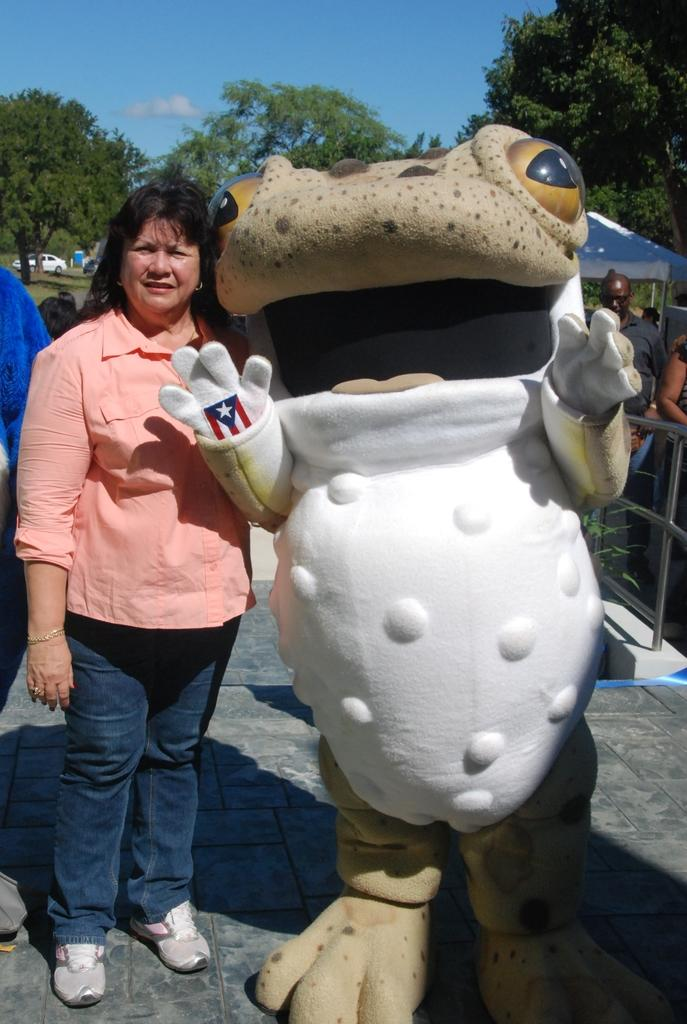Who is present in the image? There is a woman and a mascot in the image. What are the woman and the mascot doing in the image? Both the woman and the mascot are standing on the floor. What can be seen in the background of the image? There are people, a fence, a tent, a car, trees, and some objects in the background of the image. The sky is also visible. How much sugar is being used by the woman in the image? There is no indication of sugar usage in the image, as it features a woman and a mascot standing on the floor with various background elements. --- 